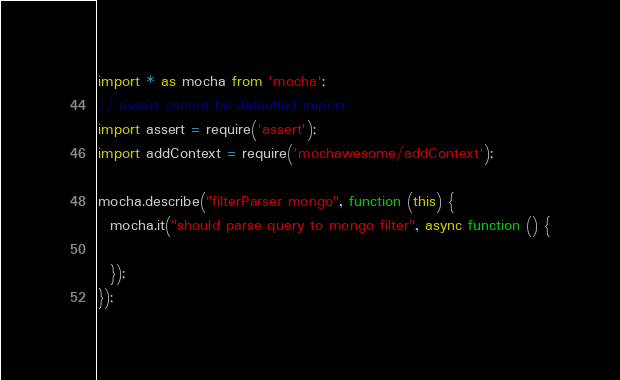Convert code to text. <code><loc_0><loc_0><loc_500><loc_500><_TypeScript_>import * as mocha from 'mocha';
// assert cannot be defaulted import
import assert = require('assert');
import addContext = require('mochawesome/addContext');

mocha.describe("filterParser mongo", function (this) {
  mocha.it("should parse query to mongo filter", async function () {
    
  });
});</code> 